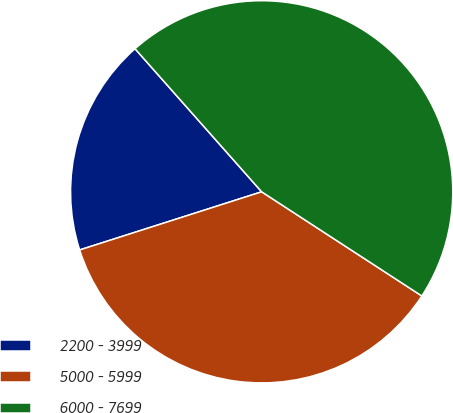Convert chart to OTSL. <chart><loc_0><loc_0><loc_500><loc_500><pie_chart><fcel>2200 - 3999<fcel>5000 - 5999<fcel>6000 - 7699<nl><fcel>18.39%<fcel>35.9%<fcel>45.71%<nl></chart> 